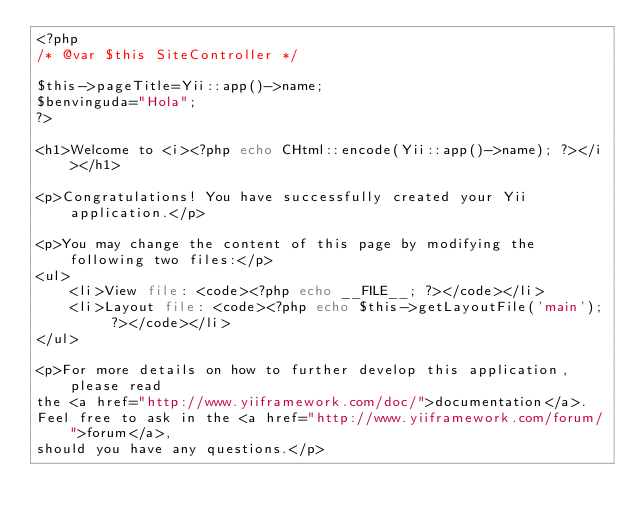<code> <loc_0><loc_0><loc_500><loc_500><_PHP_><?php
/* @var $this SiteController */

$this->pageTitle=Yii::app()->name;
$benvinguda="Hola";
?>

<h1>Welcome to <i><?php echo CHtml::encode(Yii::app()->name); ?></i></h1>

<p>Congratulations! You have successfully created your Yii application.</p>

<p>You may change the content of this page by modifying the following two files:</p>
<ul>
	<li>View file: <code><?php echo __FILE__; ?></code></li>
	<li>Layout file: <code><?php echo $this->getLayoutFile('main'); ?></code></li>
</ul>

<p>For more details on how to further develop this application, please read
the <a href="http://www.yiiframework.com/doc/">documentation</a>.
Feel free to ask in the <a href="http://www.yiiframework.com/forum/">forum</a>,
should you have any questions.</p>
</code> 